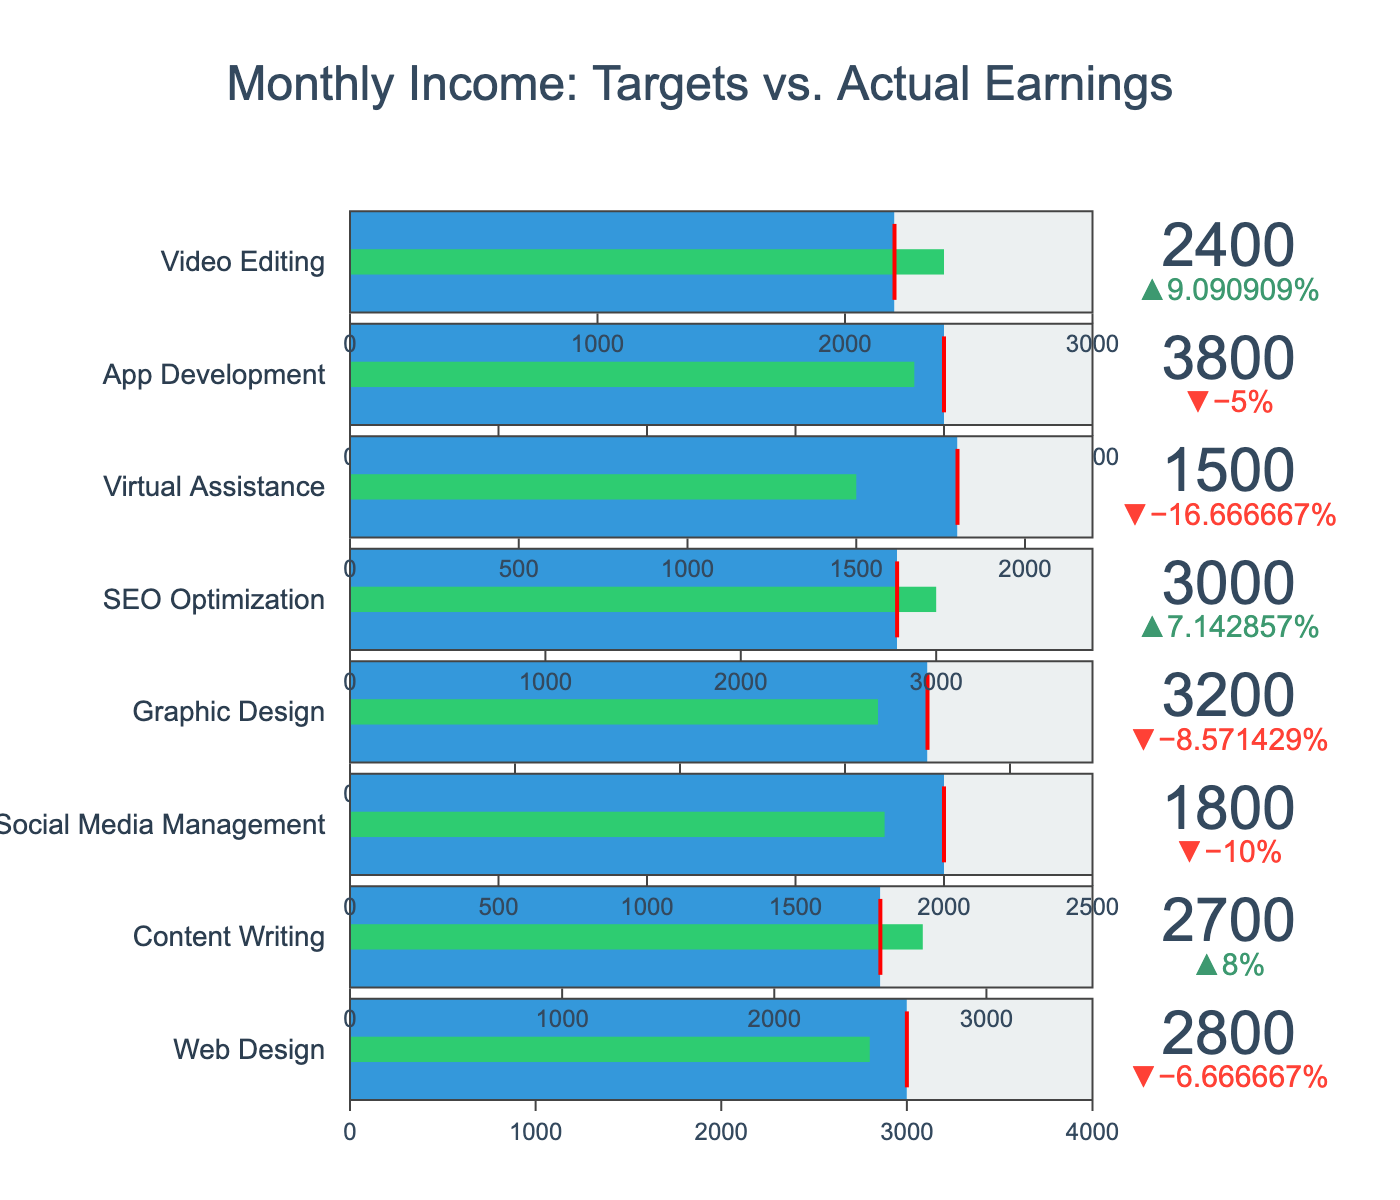What's the title of the chart? The title of the chart is located at the top of the figure. It reads "Monthly Income: Targets vs. Actual Earnings."
Answer: Monthly Income: Targets vs. Actual Earnings How many freelance projects are displayed in the chart? The chart visually displays bullet indicators for each freelance project. By counting these indicators, we can determine the number of projects. There are a total of eight projects listed.
Answer: 8 Which project has the highest actual earnings? To find the project with the highest actual earnings, look for the bullet chart with the highest value indicator. From the chart, "SEO Optimization" shows the highest actual earnings at 3000.
Answer: SEO Optimization Which project achieved the greatest percentage above its target? The delta indicator shows the relative percentage difference between actual earnings and the target for each project. By comparing these, we can see that "Content Writing" has a positive delta, indicating it exceeded its target by the greatest percentage.
Answer: Content Writing Is there any project where actual earnings were less than the target? We need to look for bullet indicators where the actual earnings (shown as the value) are lower than the target (marked by the threshold line). "Web Design," "Social Media Management," and "Virtual Assistance" are all below their targets.
Answer: Yes What are the actual and target earnings for the "App Development" project? Locate the bullet indicator for "App Development." The actual earnings are shown as the main value (3800), and the target earnings are displayed by the threshold line (4000).
Answer: Actual: 3800, Target: 4000 What is the average of the actual earnings for all projects? Sum the actual earnings for all projects and then divide by the number of projects. (2800 + 2700 + 1800 + 3200 + 3000 + 1500 + 3800 + 2400) / 8 = 24200 / 8 = 3025.
Answer: 3025 Which project has an actual earning closest to its target? To determine the closest, subtract the target from actual earnings for each project and find the smallest absolute difference. "App Development" has the smallest difference of 200 (4000 - 3800).
Answer: App Development What color is used for the bar representing the actual earnings? The color of the bar representing the actual earnings in a bullet chart is the inside bar color. In this chart, the bar color is green.
Answer: Green 